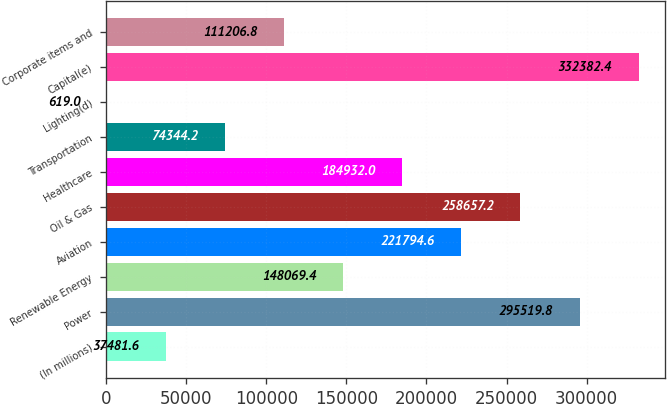<chart> <loc_0><loc_0><loc_500><loc_500><bar_chart><fcel>(In millions)<fcel>Power<fcel>Renewable Energy<fcel>Aviation<fcel>Oil & Gas<fcel>Healthcare<fcel>Transportation<fcel>Lighting(d)<fcel>Capital(e)<fcel>Corporate items and<nl><fcel>37481.6<fcel>295520<fcel>148069<fcel>221795<fcel>258657<fcel>184932<fcel>74344.2<fcel>619<fcel>332382<fcel>111207<nl></chart> 